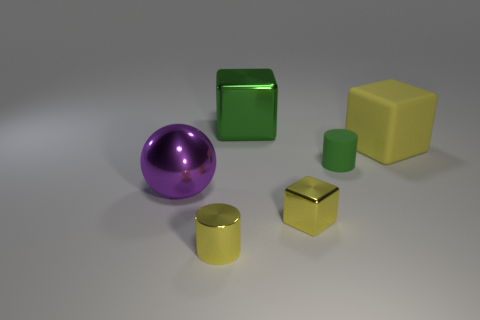Add 3 big metal cubes. How many objects exist? 9 Subtract all spheres. How many objects are left? 5 Subtract 0 brown blocks. How many objects are left? 6 Subtract all yellow matte cubes. Subtract all small red shiny balls. How many objects are left? 5 Add 2 big purple objects. How many big purple objects are left? 3 Add 5 blocks. How many blocks exist? 8 